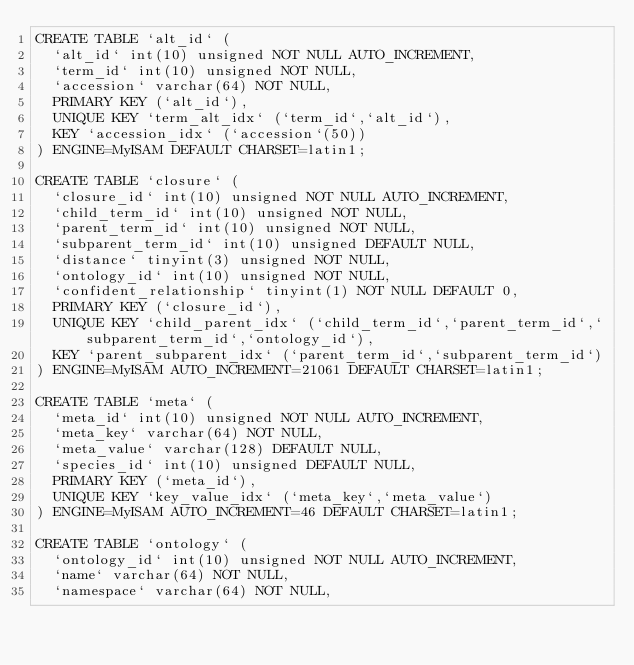Convert code to text. <code><loc_0><loc_0><loc_500><loc_500><_SQL_>CREATE TABLE `alt_id` (
  `alt_id` int(10) unsigned NOT NULL AUTO_INCREMENT,
  `term_id` int(10) unsigned NOT NULL,
  `accession` varchar(64) NOT NULL,
  PRIMARY KEY (`alt_id`),
  UNIQUE KEY `term_alt_idx` (`term_id`,`alt_id`),
  KEY `accession_idx` (`accession`(50))
) ENGINE=MyISAM DEFAULT CHARSET=latin1;

CREATE TABLE `closure` (
  `closure_id` int(10) unsigned NOT NULL AUTO_INCREMENT,
  `child_term_id` int(10) unsigned NOT NULL,
  `parent_term_id` int(10) unsigned NOT NULL,
  `subparent_term_id` int(10) unsigned DEFAULT NULL,
  `distance` tinyint(3) unsigned NOT NULL,
  `ontology_id` int(10) unsigned NOT NULL,
  `confident_relationship` tinyint(1) NOT NULL DEFAULT 0,
  PRIMARY KEY (`closure_id`),
  UNIQUE KEY `child_parent_idx` (`child_term_id`,`parent_term_id`,`subparent_term_id`,`ontology_id`),
  KEY `parent_subparent_idx` (`parent_term_id`,`subparent_term_id`)
) ENGINE=MyISAM AUTO_INCREMENT=21061 DEFAULT CHARSET=latin1;

CREATE TABLE `meta` (
  `meta_id` int(10) unsigned NOT NULL AUTO_INCREMENT,
  `meta_key` varchar(64) NOT NULL,
  `meta_value` varchar(128) DEFAULT NULL,
  `species_id` int(10) unsigned DEFAULT NULL,
  PRIMARY KEY (`meta_id`),
  UNIQUE KEY `key_value_idx` (`meta_key`,`meta_value`)
) ENGINE=MyISAM AUTO_INCREMENT=46 DEFAULT CHARSET=latin1;

CREATE TABLE `ontology` (
  `ontology_id` int(10) unsigned NOT NULL AUTO_INCREMENT,
  `name` varchar(64) NOT NULL,
  `namespace` varchar(64) NOT NULL,</code> 